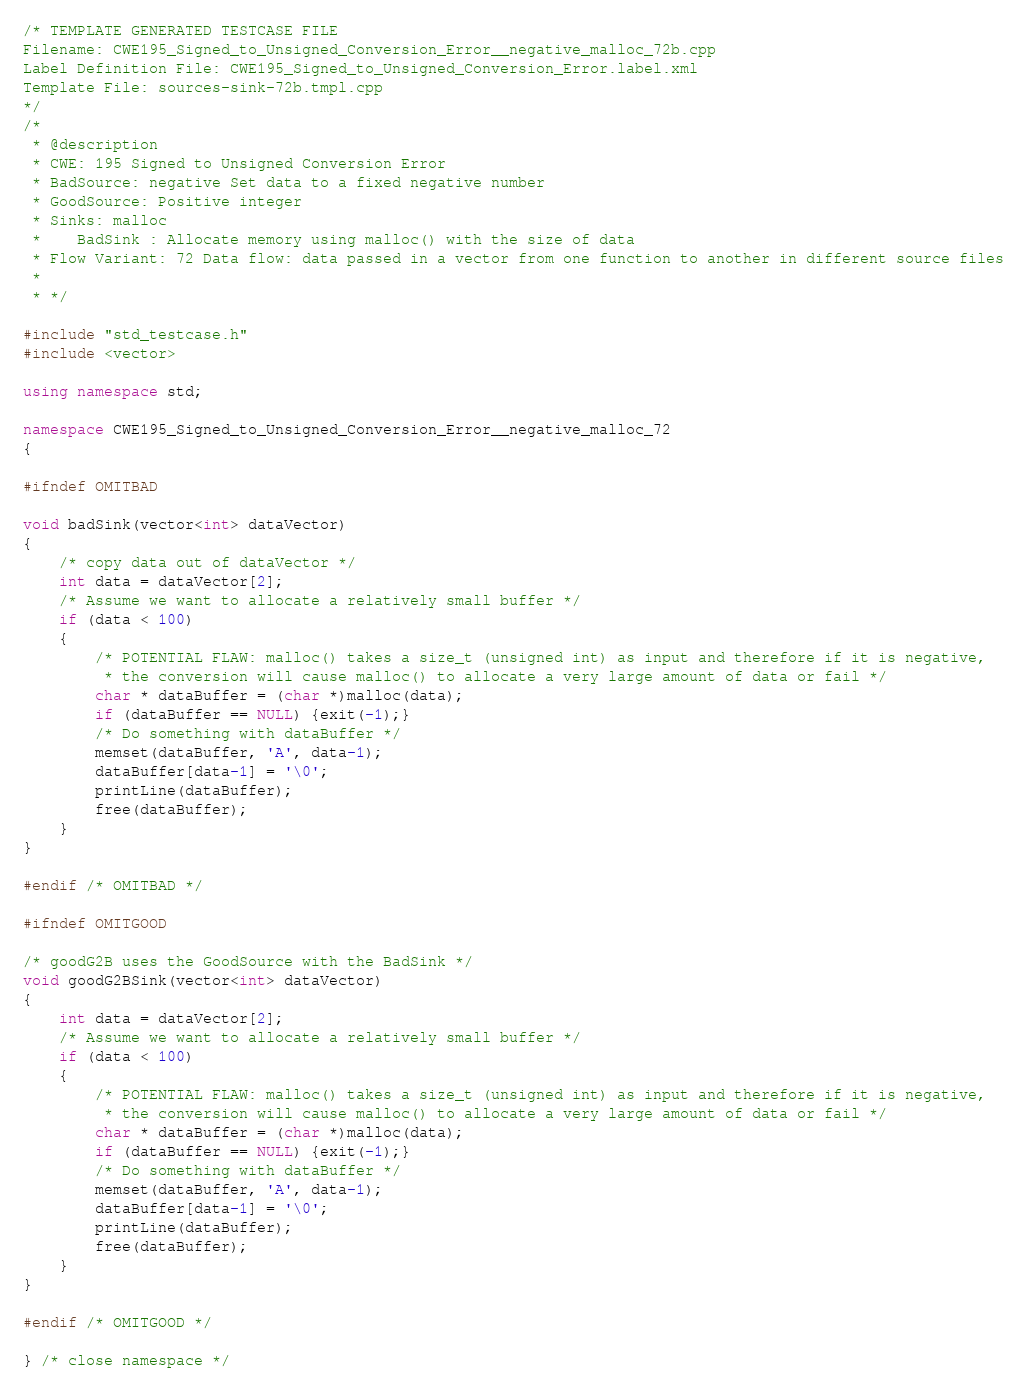Convert code to text. <code><loc_0><loc_0><loc_500><loc_500><_C++_>/* TEMPLATE GENERATED TESTCASE FILE
Filename: CWE195_Signed_to_Unsigned_Conversion_Error__negative_malloc_72b.cpp
Label Definition File: CWE195_Signed_to_Unsigned_Conversion_Error.label.xml
Template File: sources-sink-72b.tmpl.cpp
*/
/*
 * @description
 * CWE: 195 Signed to Unsigned Conversion Error
 * BadSource: negative Set data to a fixed negative number
 * GoodSource: Positive integer
 * Sinks: malloc
 *    BadSink : Allocate memory using malloc() with the size of data
 * Flow Variant: 72 Data flow: data passed in a vector from one function to another in different source files
 *
 * */

#include "std_testcase.h"
#include <vector>

using namespace std;

namespace CWE195_Signed_to_Unsigned_Conversion_Error__negative_malloc_72
{

#ifndef OMITBAD

void badSink(vector<int> dataVector)
{
    /* copy data out of dataVector */
    int data = dataVector[2];
    /* Assume we want to allocate a relatively small buffer */
    if (data < 100)
    {
        /* POTENTIAL FLAW: malloc() takes a size_t (unsigned int) as input and therefore if it is negative,
         * the conversion will cause malloc() to allocate a very large amount of data or fail */
        char * dataBuffer = (char *)malloc(data);
        if (dataBuffer == NULL) {exit(-1);}
        /* Do something with dataBuffer */
        memset(dataBuffer, 'A', data-1);
        dataBuffer[data-1] = '\0';
        printLine(dataBuffer);
        free(dataBuffer);
    }
}

#endif /* OMITBAD */

#ifndef OMITGOOD

/* goodG2B uses the GoodSource with the BadSink */
void goodG2BSink(vector<int> dataVector)
{
    int data = dataVector[2];
    /* Assume we want to allocate a relatively small buffer */
    if (data < 100)
    {
        /* POTENTIAL FLAW: malloc() takes a size_t (unsigned int) as input and therefore if it is negative,
         * the conversion will cause malloc() to allocate a very large amount of data or fail */
        char * dataBuffer = (char *)malloc(data);
        if (dataBuffer == NULL) {exit(-1);}
        /* Do something with dataBuffer */
        memset(dataBuffer, 'A', data-1);
        dataBuffer[data-1] = '\0';
        printLine(dataBuffer);
        free(dataBuffer);
    }
}

#endif /* OMITGOOD */

} /* close namespace */
</code> 